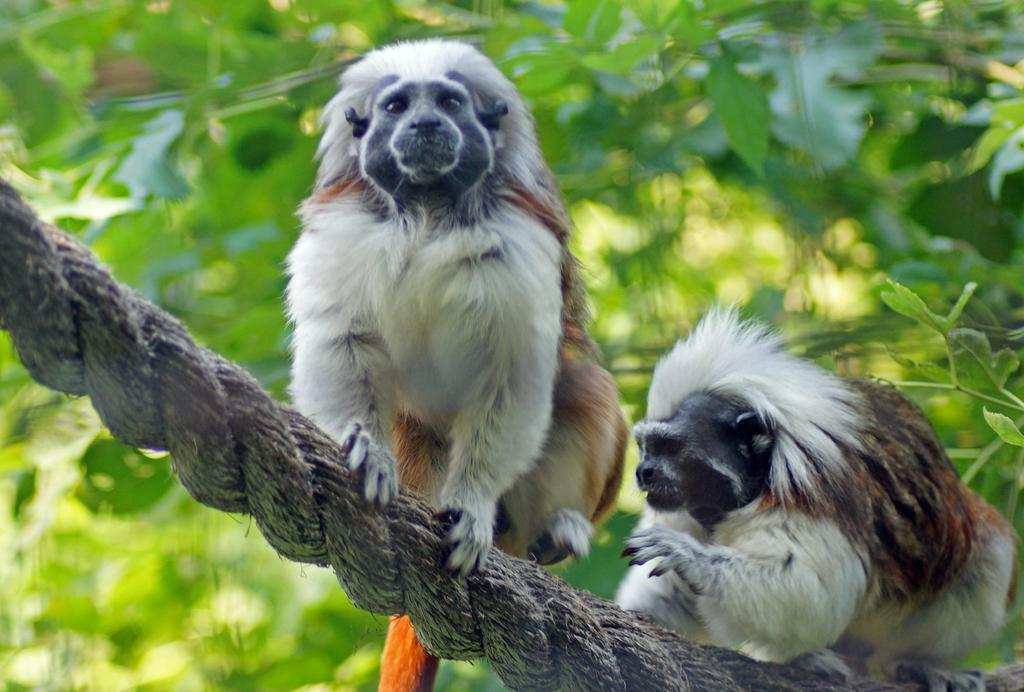What is the main subject of the image? There are two animals in the image. How are the animals positioned in the image? The animals are on a rope. What type of vegetation can be seen in the image? There are leaves visible in the image, from left to right. Can you describe the background of the image? The background of the image is blurry. What type of engine can be seen powering the ship in the image? There is no ship or engine present in the image; it features two animals on a rope with leaves in the background. 